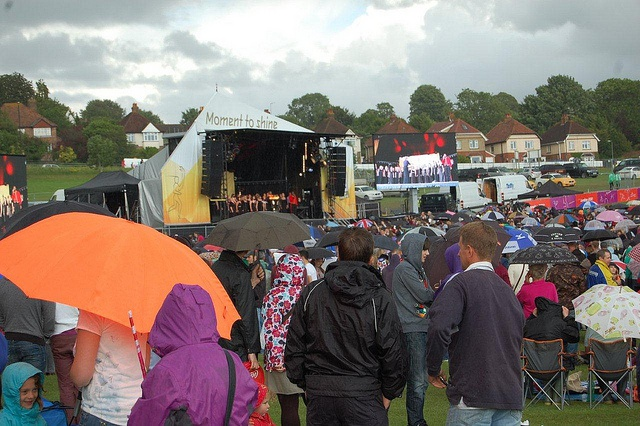Describe the objects in this image and their specific colors. I can see people in darkgray, black, gray, and darkgreen tones, umbrella in darkgray, salmon, red, and black tones, people in darkgray, black, and gray tones, people in darkgray, purple, and black tones, and people in darkgray, black, gray, and lightgray tones in this image. 